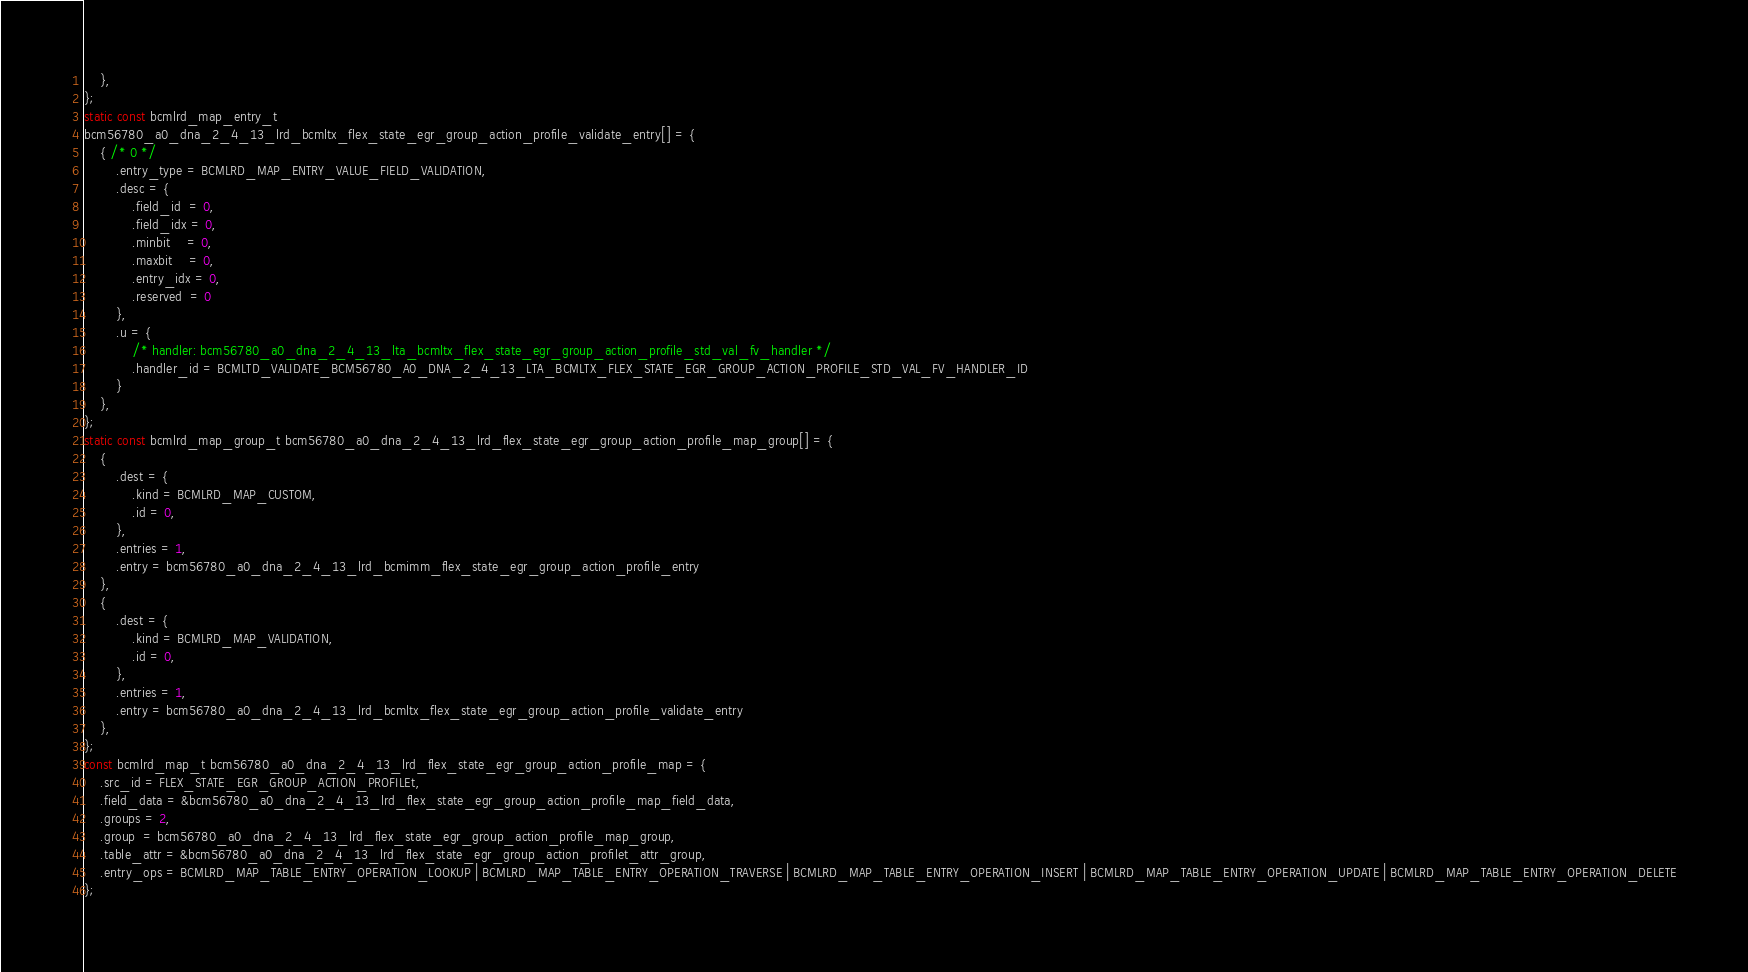<code> <loc_0><loc_0><loc_500><loc_500><_C_>    },
};
static const bcmlrd_map_entry_t
bcm56780_a0_dna_2_4_13_lrd_bcmltx_flex_state_egr_group_action_profile_validate_entry[] = {
    { /* 0 */
        .entry_type = BCMLRD_MAP_ENTRY_VALUE_FIELD_VALIDATION,
        .desc = {
            .field_id  = 0,
            .field_idx = 0,
            .minbit    = 0,
            .maxbit    = 0,
            .entry_idx = 0,
            .reserved  = 0
        },
        .u = {
            /* handler: bcm56780_a0_dna_2_4_13_lta_bcmltx_flex_state_egr_group_action_profile_std_val_fv_handler */
            .handler_id = BCMLTD_VALIDATE_BCM56780_A0_DNA_2_4_13_LTA_BCMLTX_FLEX_STATE_EGR_GROUP_ACTION_PROFILE_STD_VAL_FV_HANDLER_ID
        }
    },
};
static const bcmlrd_map_group_t bcm56780_a0_dna_2_4_13_lrd_flex_state_egr_group_action_profile_map_group[] = {
    {
        .dest = {
            .kind = BCMLRD_MAP_CUSTOM,
            .id = 0,
        },
        .entries = 1,
        .entry = bcm56780_a0_dna_2_4_13_lrd_bcmimm_flex_state_egr_group_action_profile_entry
    },
    {
        .dest = {
            .kind = BCMLRD_MAP_VALIDATION,
            .id = 0,
        },
        .entries = 1,
        .entry = bcm56780_a0_dna_2_4_13_lrd_bcmltx_flex_state_egr_group_action_profile_validate_entry
    },
};
const bcmlrd_map_t bcm56780_a0_dna_2_4_13_lrd_flex_state_egr_group_action_profile_map = {
    .src_id = FLEX_STATE_EGR_GROUP_ACTION_PROFILEt,
    .field_data = &bcm56780_a0_dna_2_4_13_lrd_flex_state_egr_group_action_profile_map_field_data,
    .groups = 2,
    .group  = bcm56780_a0_dna_2_4_13_lrd_flex_state_egr_group_action_profile_map_group,
    .table_attr = &bcm56780_a0_dna_2_4_13_lrd_flex_state_egr_group_action_profilet_attr_group,
    .entry_ops = BCMLRD_MAP_TABLE_ENTRY_OPERATION_LOOKUP | BCMLRD_MAP_TABLE_ENTRY_OPERATION_TRAVERSE | BCMLRD_MAP_TABLE_ENTRY_OPERATION_INSERT | BCMLRD_MAP_TABLE_ENTRY_OPERATION_UPDATE | BCMLRD_MAP_TABLE_ENTRY_OPERATION_DELETE
};
</code> 